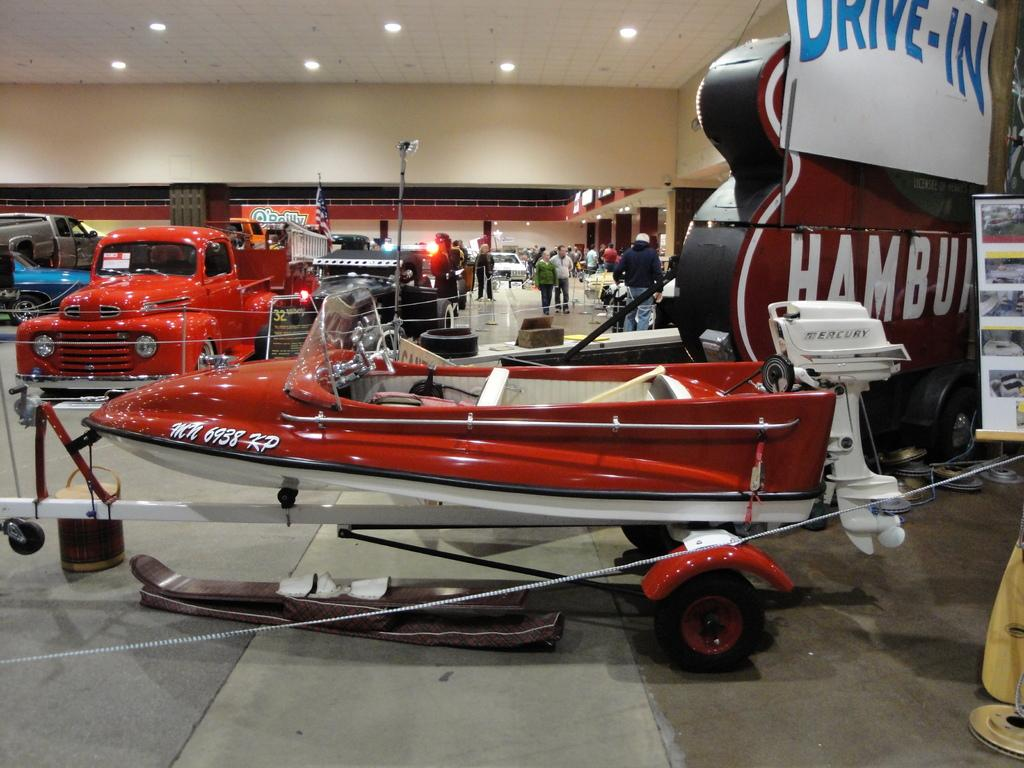What type of vehicle is present in the image? There is a boat and a car in the image. What is the shape of the hoarding in the image? The hoarding in the image is guitar-shaped. What object can be seen in the image that is typically used for writing or reading? There is a paper in the image. What type of objects are present in the image that are used for construction or display purposes? There are boards in the image. What type of objects are present in the image that are used for transportation? There are vehicles in the image. What can be seen in the image that suggests the presence of people? There is a group of people standing in the image. What can be seen in the image that provides illumination? There are lights in the image. What type of protest is taking place in the image? There is no protest present in the image. What part of the body can be seen in the image that is used for bending the knee? There are no body parts visible in the image, including knees. 